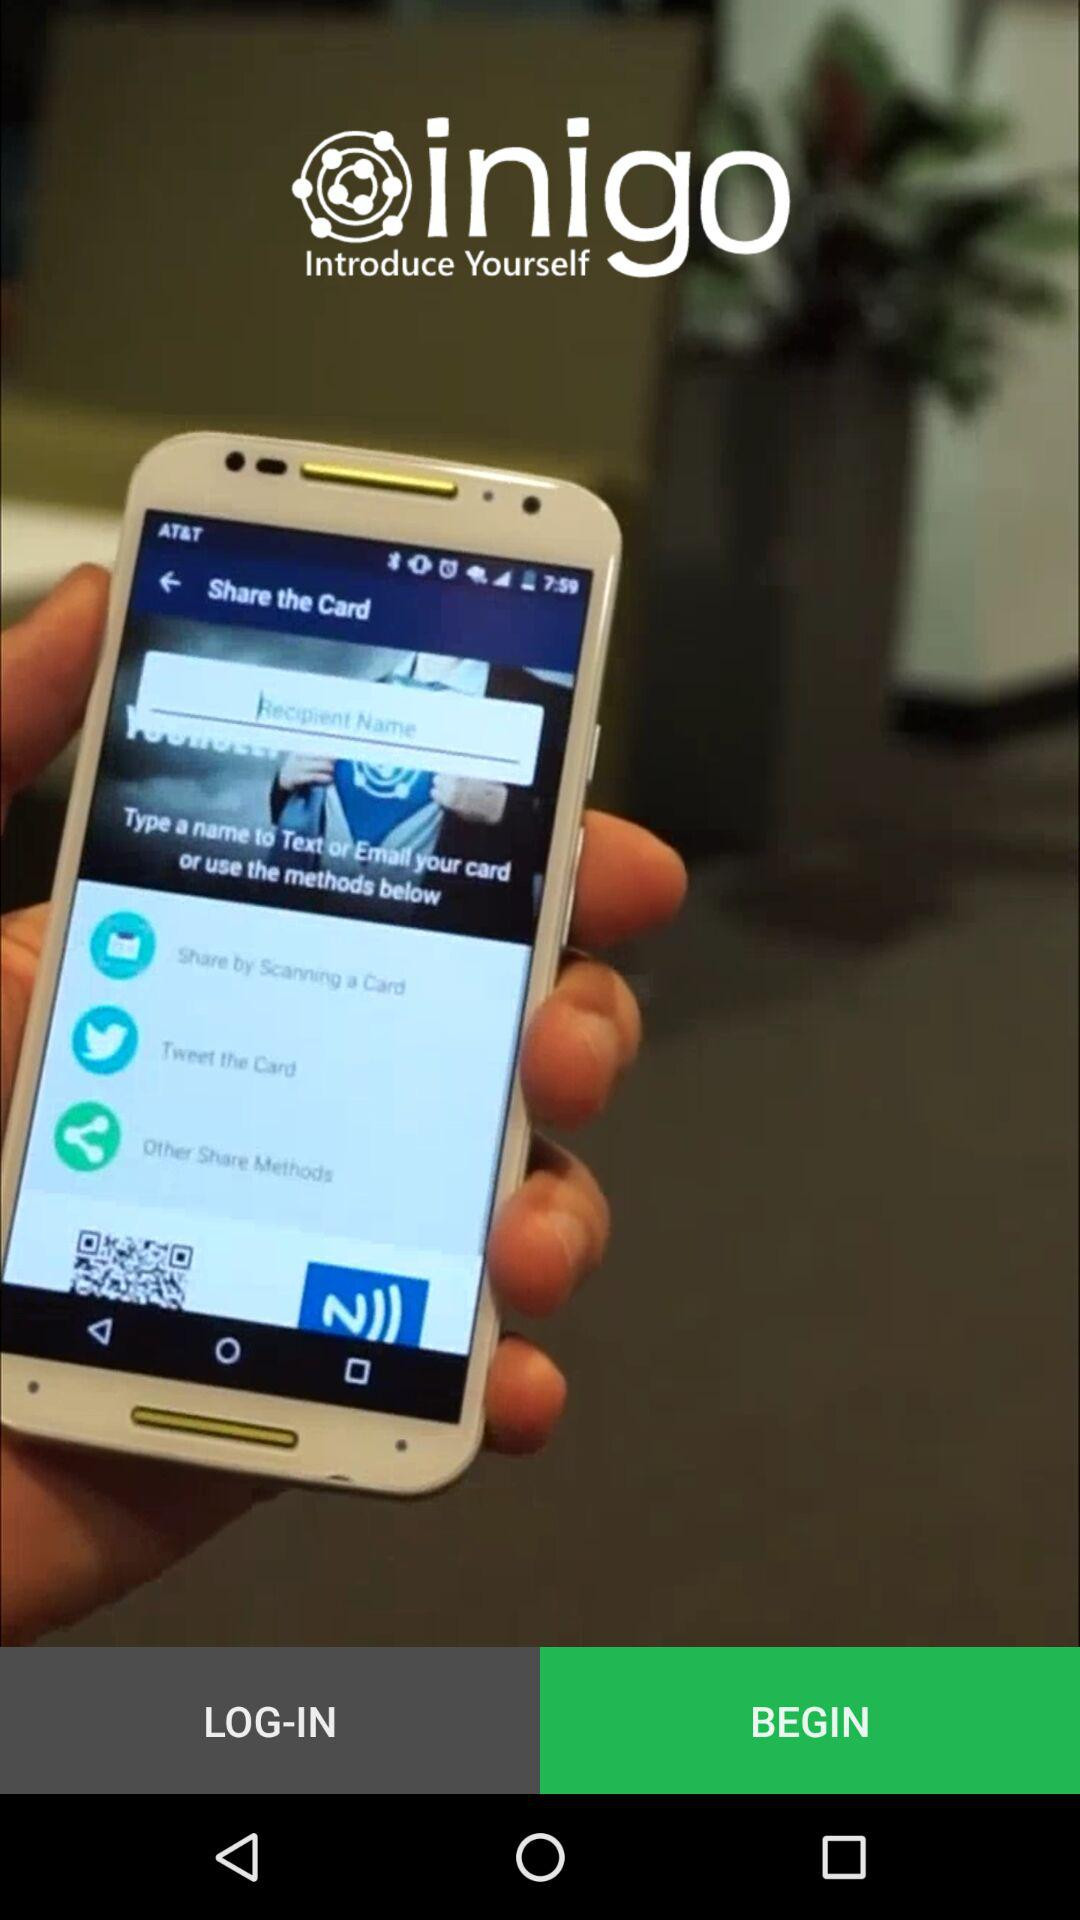What is the function of the NFC icon displayed on the smartphone screen? The NFC icon indicates that the smartphone supports Near Field Communication, allowing for contactless data transfer. In this context, it likely enables sharing the card information with another NFC-enabled device by just tapping them together. How secure is using NFC for such transfers? NFC transfers are generally secure as they require physical proximity, typically less than 4 cm, reducing the risk of interception. Additionally, NFC often involves encryption to protect the data during the exchange. 